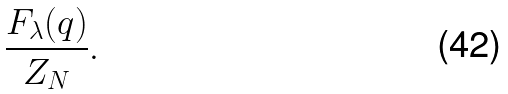Convert formula to latex. <formula><loc_0><loc_0><loc_500><loc_500>\frac { F _ { \lambda } ( q ) } { Z _ { N } } .</formula> 